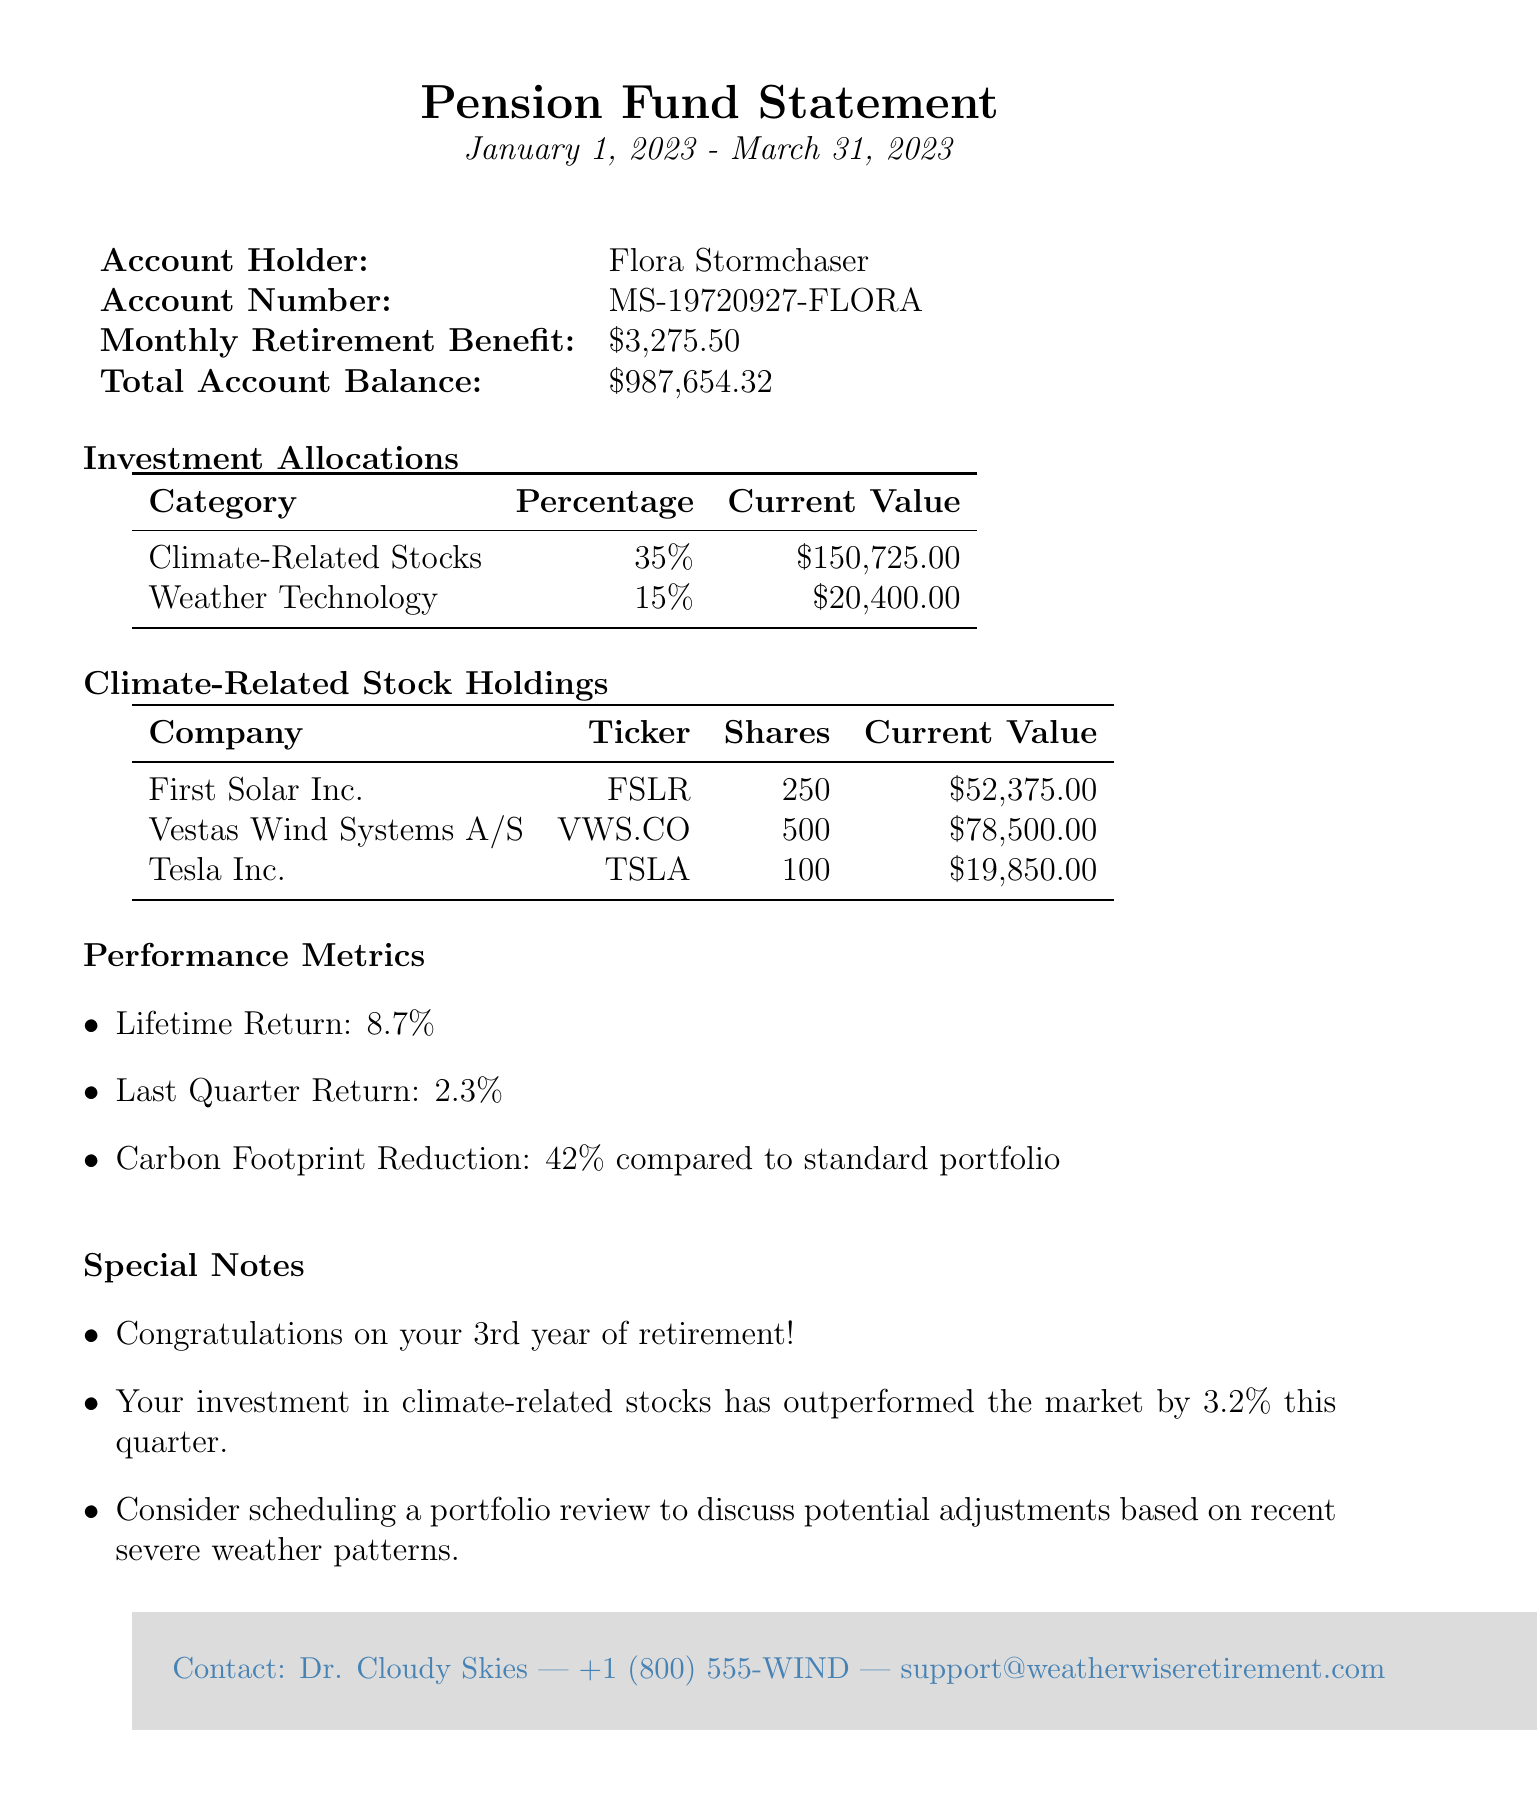What is the name of the pension fund? The pension fund name is directly stated in the document as WeatherWise Retirement Solutions.
Answer: WeatherWise Retirement Solutions Who is the account holder? The account holder's name is listed near the top of the document.
Answer: Flora Stormchaser What is the monthly retirement benefit? The monthly retirement benefit is specified in the table of account information.
Answer: $3,275.50 What is the total account balance? The total account balance is presented in the account information section of the document.
Answer: $987,654.32 What percentage of the investment is allocated to Climate-Related Stocks? The investment allocation percentage for Climate-Related Stocks is provided in the investment allocations section.
Answer: 35% How many shares of Tesla Inc. are held? The number of shares for Tesla Inc. is specified in the climate-related stock holdings table.
Answer: 100 What is the carbon footprint reduction percentage? The carbon footprint reduction is mentioned in the performance metrics section.
Answer: 42% What was the last quarter return? The last quarter return is provided in the performance metrics and indicates recent performance.
Answer: 2.3% What special note congratulates Flora? One of the special notes specifically acknowledges Flora's retirement milestone.
Answer: Congratulations on your 3rd year of retirement! 